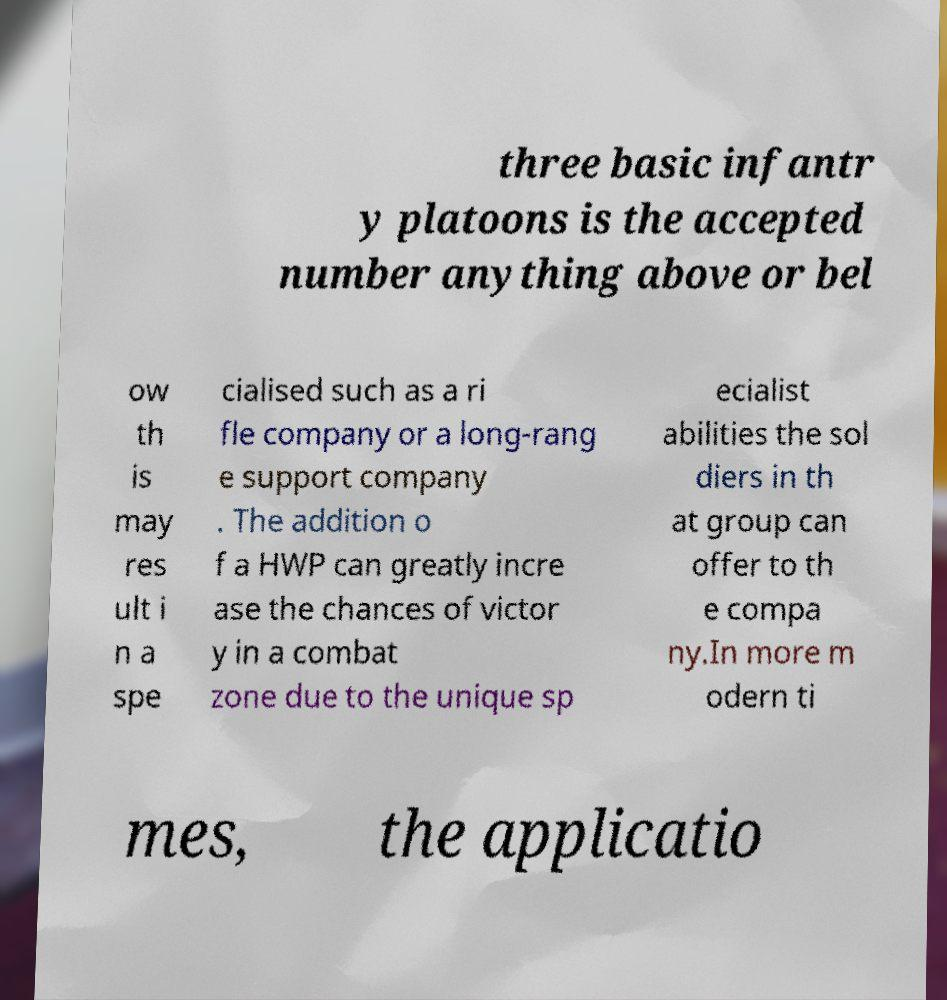There's text embedded in this image that I need extracted. Can you transcribe it verbatim? three basic infantr y platoons is the accepted number anything above or bel ow th is may res ult i n a spe cialised such as a ri fle company or a long-rang e support company . The addition o f a HWP can greatly incre ase the chances of victor y in a combat zone due to the unique sp ecialist abilities the sol diers in th at group can offer to th e compa ny.In more m odern ti mes, the applicatio 